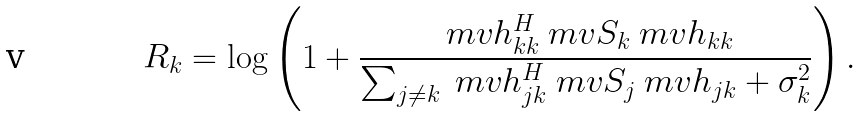<formula> <loc_0><loc_0><loc_500><loc_500>R _ { k } = \log \left ( 1 + \frac { \ m v { h } _ { k k } ^ { H } \ m v { S } _ { k } \ m v { h } _ { k k } } { \sum _ { j \neq k } \ m v { h } _ { j k } ^ { H } \ m v { S } _ { j } \ m v { h } _ { j k } + \sigma _ { k } ^ { 2 } } \right ) .</formula> 